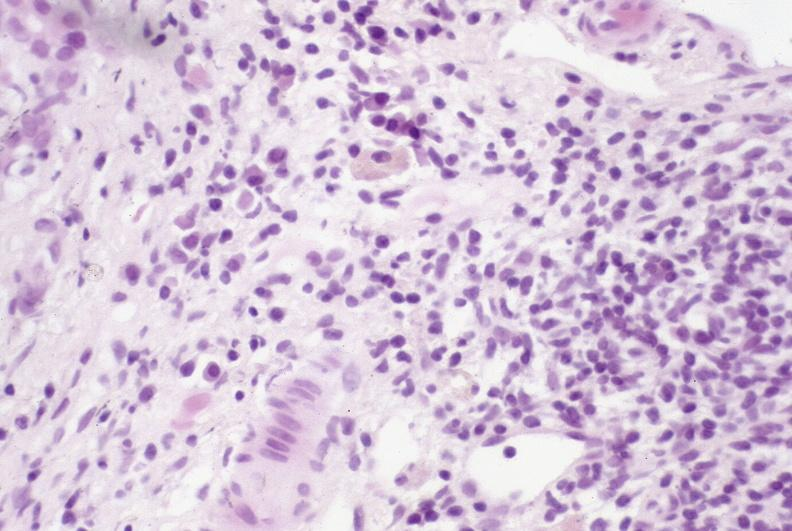does this protocol show primary sclerosing cholangitis?
Answer the question using a single word or phrase. No 